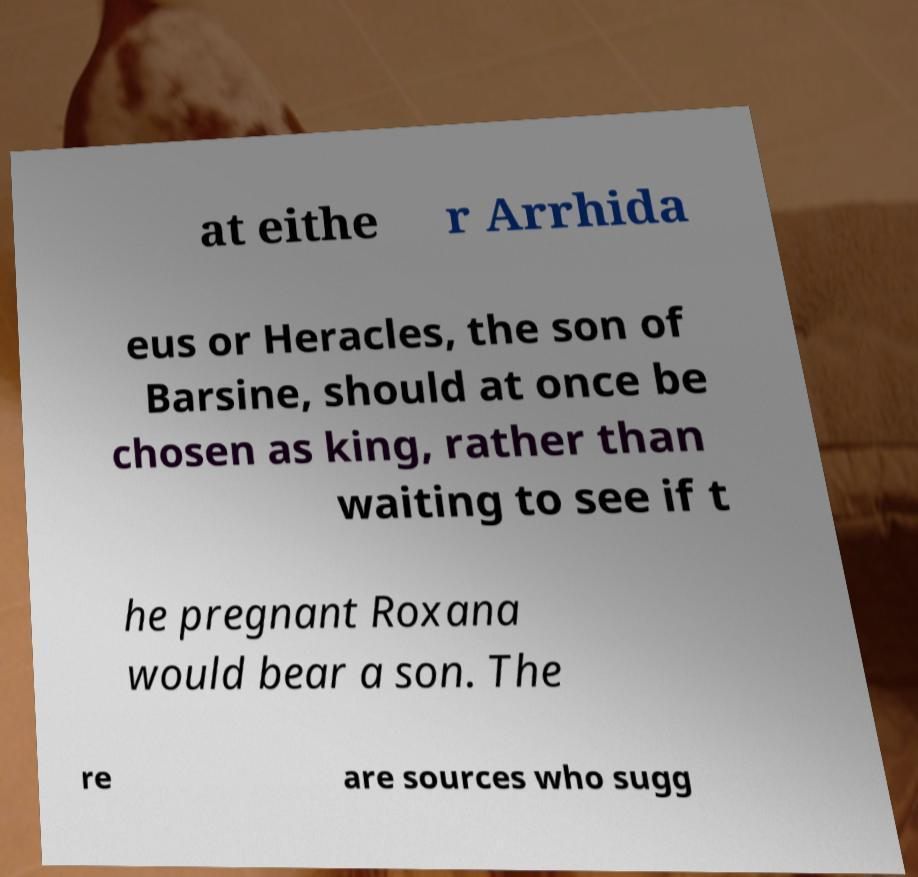Could you extract and type out the text from this image? at eithe r Arrhida eus or Heracles, the son of Barsine, should at once be chosen as king, rather than waiting to see if t he pregnant Roxana would bear a son. The re are sources who sugg 